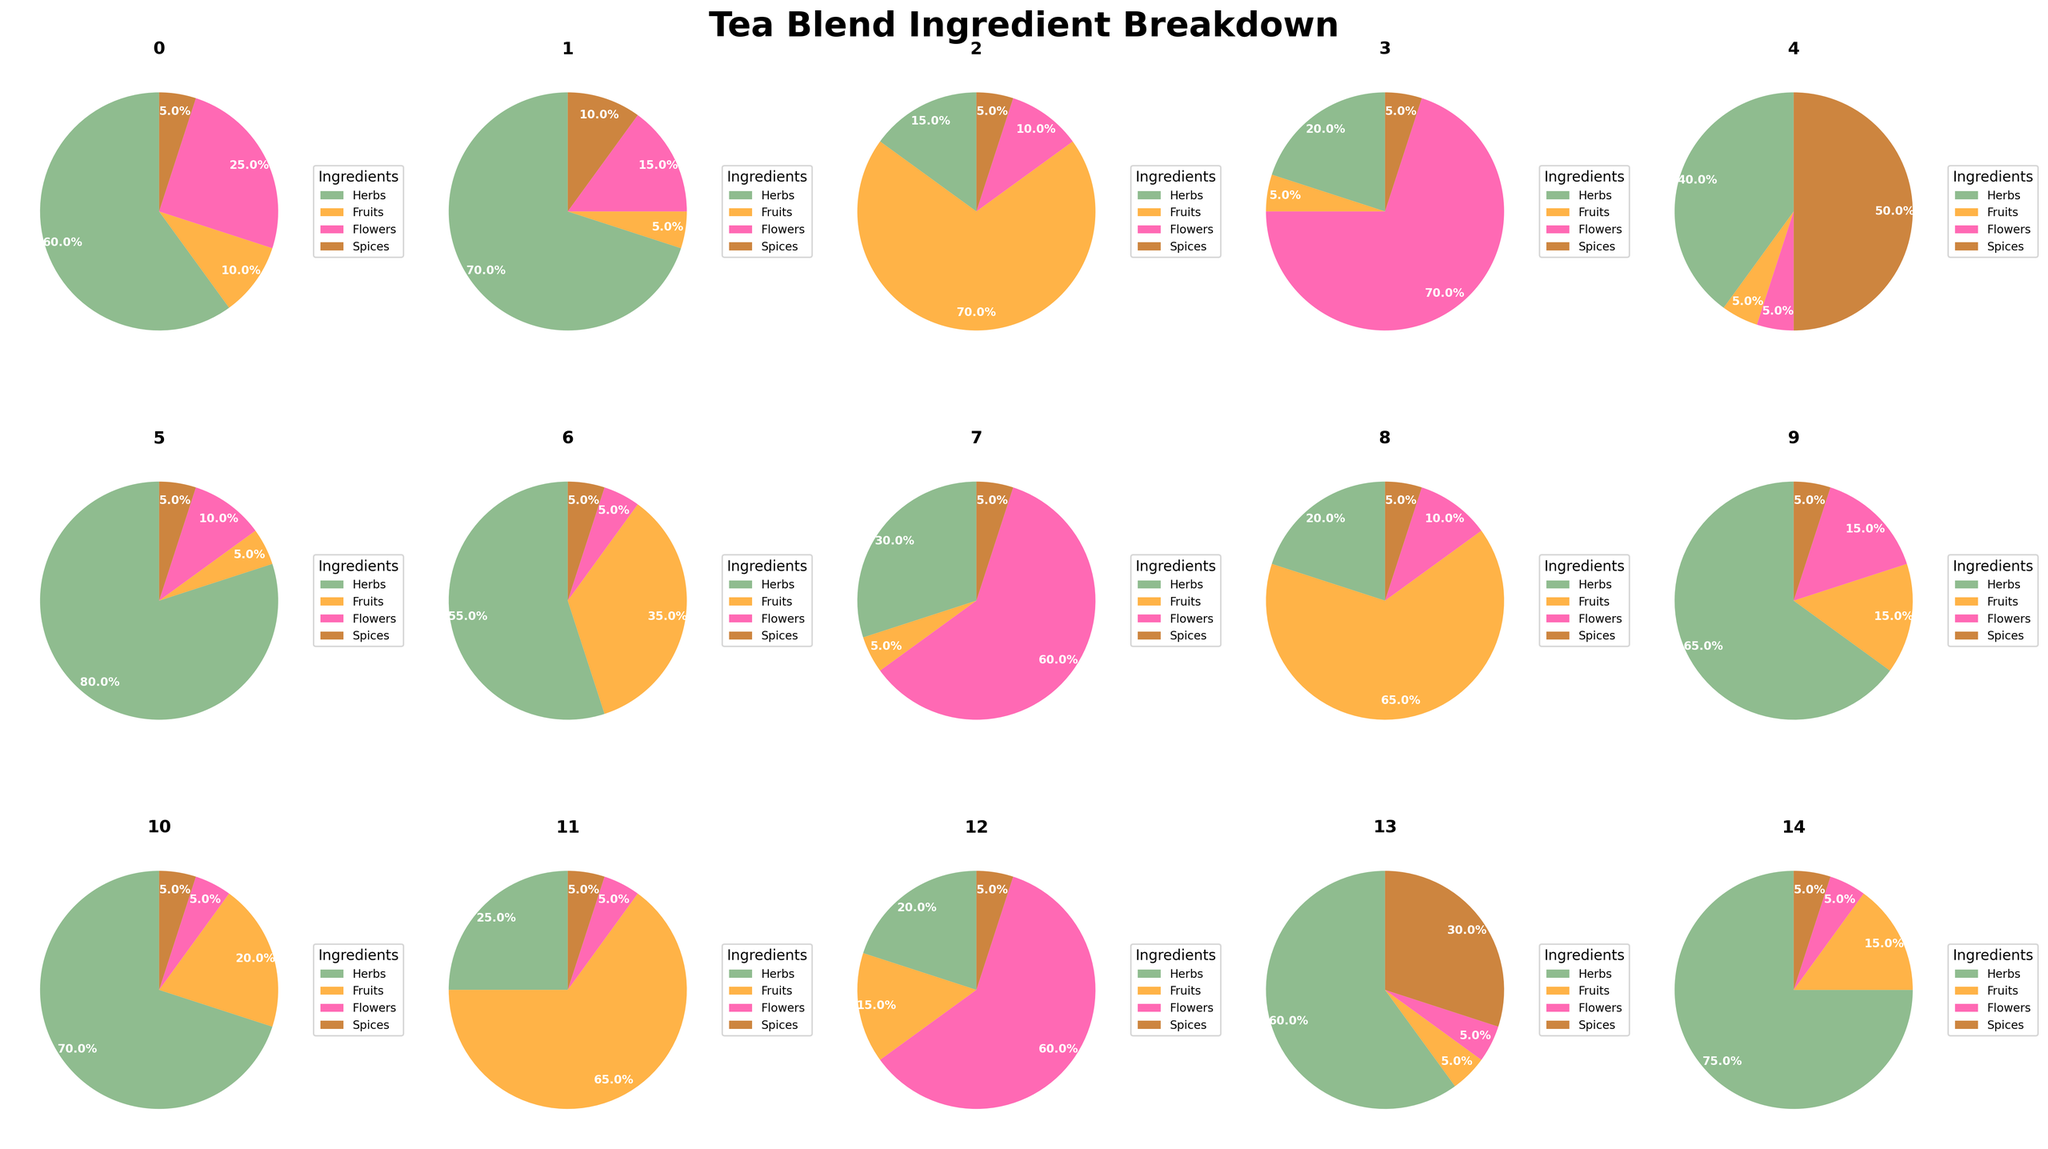Which tea blend has the highest percentage of herbs? Find the tea blend with the largest portion in the "Herbs" category from the pie charts. "Mint Medley" has 80% herbs.
Answer: Mint Medley What's the combined percentage of flowers in Lavender Dreams and Hibiscus Harmony? Check the flower percentages for "Lavender Dreams" and "Hibiscus Harmony" and sum them up, which are 60% and 60%, respectively. So, 60% + 60% = 120%.
Answer: 120% Which tea blend has the smallest percentage of fruits? Identify the blend with the smallest portion in the "Fruits" category by comparing all pie charts. Both "Earl Grey Blend", "Floral Delight", "Mint Medley", "Lavender Dreams", "Spiced Chai", "Green Tea Blend", "Vanilla Comfort", and "Herbal Detox" have 5% fruits. Any of these blends can be an answer.
Answer: Earl Grey Blend (or any of the others with 5% fruits) Is there any tea blend with an equal percentage of spices and fruits? Look for all blends where the segments for "Spices" and "Fruits" are equal. Both "Fruit Fusion" and "Berry Bliss" have 5% spices and 5% fruits. Any of these blends can be an answer.
Answer: Fruit Fusion (or Berry Bliss) Which blend has a higher percentage of flowers, Chamomile Blend or Citrus Zinger? Compare the "Flowers" segments of both "Chamomile Blend" and "Citrus Zinger". "Chamomile Blend" has 25% flowers, while "Citrus Zinger" has 5%.
Answer: Chamomile Blend What is the average percentage of herbs across all tea blends? Sum all the herb percentages from each pie chart and divide by the number of blends. (60+70+15+20+40+80+55+30+20+65+70+25+20+60+75) / 15 = 705 / 15 = 47%.
Answer: 47% Does any blend have more than 50% of both herbs and another ingredient (fruit, flowers, or spices)? Check all blends where more than 50% appears in both herbs and any of the other ingredients. No such blend exists as no pie chart meets this criterion.
Answer: No Which blend has the nearest equal distribution among all four categories? Look for the pie chart where the segments are most balanced. "Vanilla Comfort" seems to have a similar distribution (60% herbs, 5% fruits, 5% flowers, 30% spices).
Answer: Vanilla Comfort Which two tea blends have the closest percentage of herbs? Find the two blends with the herb percentages closest to each other. "Chamomile Blend" (60%) and "Vanilla Comfort" (60%) have the same percentage.
Answer: Chamomile Blend and Vanilla Comfort 